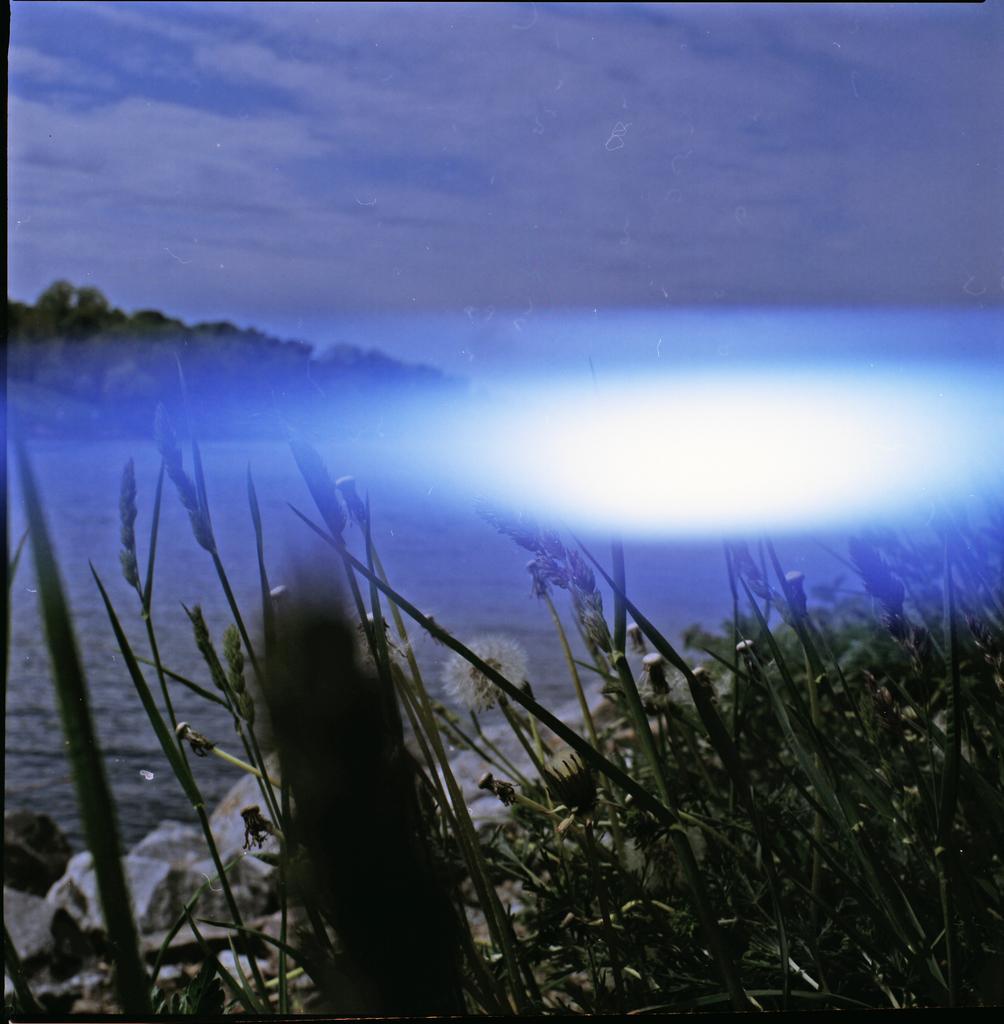Could you give a brief overview of what you see in this image? In this image I can see at the bottom there are plants. In the middle there is water, at the top it is the cloudy sky. 